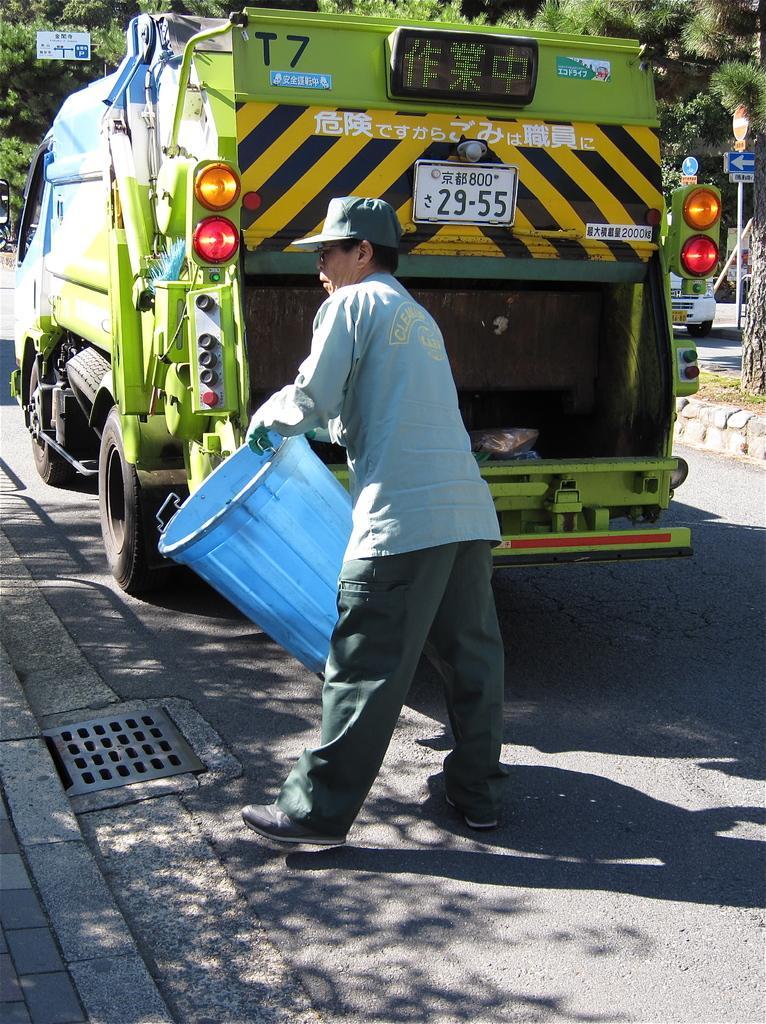Please provide a concise description of this image. In the picture we can see a man standing and holding a bucket which is blue in color and throwing something in the drainage and behind him we can see a truck, which is green in color with some lights and in the background we can see some poles with direction board and some trees beside it. 